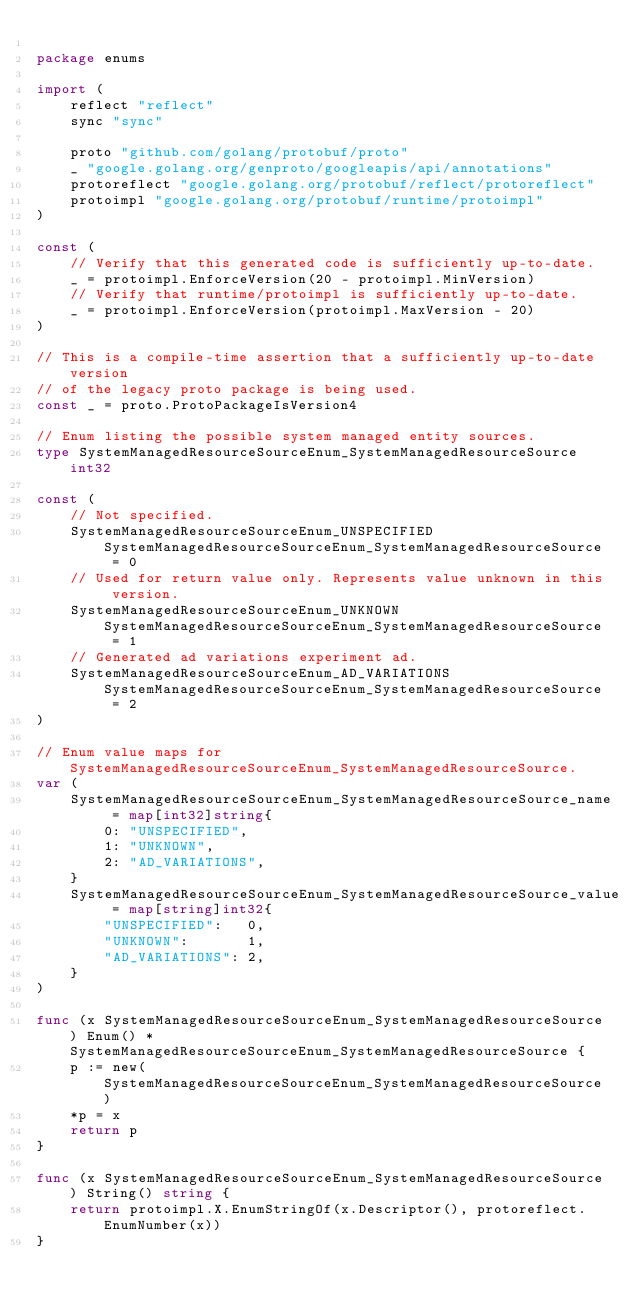Convert code to text. <code><loc_0><loc_0><loc_500><loc_500><_Go_>
package enums

import (
	reflect "reflect"
	sync "sync"

	proto "github.com/golang/protobuf/proto"
	_ "google.golang.org/genproto/googleapis/api/annotations"
	protoreflect "google.golang.org/protobuf/reflect/protoreflect"
	protoimpl "google.golang.org/protobuf/runtime/protoimpl"
)

const (
	// Verify that this generated code is sufficiently up-to-date.
	_ = protoimpl.EnforceVersion(20 - protoimpl.MinVersion)
	// Verify that runtime/protoimpl is sufficiently up-to-date.
	_ = protoimpl.EnforceVersion(protoimpl.MaxVersion - 20)
)

// This is a compile-time assertion that a sufficiently up-to-date version
// of the legacy proto package is being used.
const _ = proto.ProtoPackageIsVersion4

// Enum listing the possible system managed entity sources.
type SystemManagedResourceSourceEnum_SystemManagedResourceSource int32

const (
	// Not specified.
	SystemManagedResourceSourceEnum_UNSPECIFIED SystemManagedResourceSourceEnum_SystemManagedResourceSource = 0
	// Used for return value only. Represents value unknown in this version.
	SystemManagedResourceSourceEnum_UNKNOWN SystemManagedResourceSourceEnum_SystemManagedResourceSource = 1
	// Generated ad variations experiment ad.
	SystemManagedResourceSourceEnum_AD_VARIATIONS SystemManagedResourceSourceEnum_SystemManagedResourceSource = 2
)

// Enum value maps for SystemManagedResourceSourceEnum_SystemManagedResourceSource.
var (
	SystemManagedResourceSourceEnum_SystemManagedResourceSource_name = map[int32]string{
		0: "UNSPECIFIED",
		1: "UNKNOWN",
		2: "AD_VARIATIONS",
	}
	SystemManagedResourceSourceEnum_SystemManagedResourceSource_value = map[string]int32{
		"UNSPECIFIED":   0,
		"UNKNOWN":       1,
		"AD_VARIATIONS": 2,
	}
)

func (x SystemManagedResourceSourceEnum_SystemManagedResourceSource) Enum() *SystemManagedResourceSourceEnum_SystemManagedResourceSource {
	p := new(SystemManagedResourceSourceEnum_SystemManagedResourceSource)
	*p = x
	return p
}

func (x SystemManagedResourceSourceEnum_SystemManagedResourceSource) String() string {
	return protoimpl.X.EnumStringOf(x.Descriptor(), protoreflect.EnumNumber(x))
}
</code> 